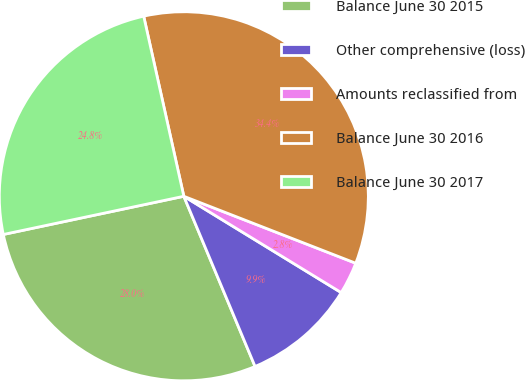Convert chart. <chart><loc_0><loc_0><loc_500><loc_500><pie_chart><fcel>Balance June 30 2015<fcel>Other comprehensive (loss)<fcel>Amounts reclassified from<fcel>Balance June 30 2016<fcel>Balance June 30 2017<nl><fcel>27.99%<fcel>9.95%<fcel>2.83%<fcel>34.4%<fcel>24.83%<nl></chart> 